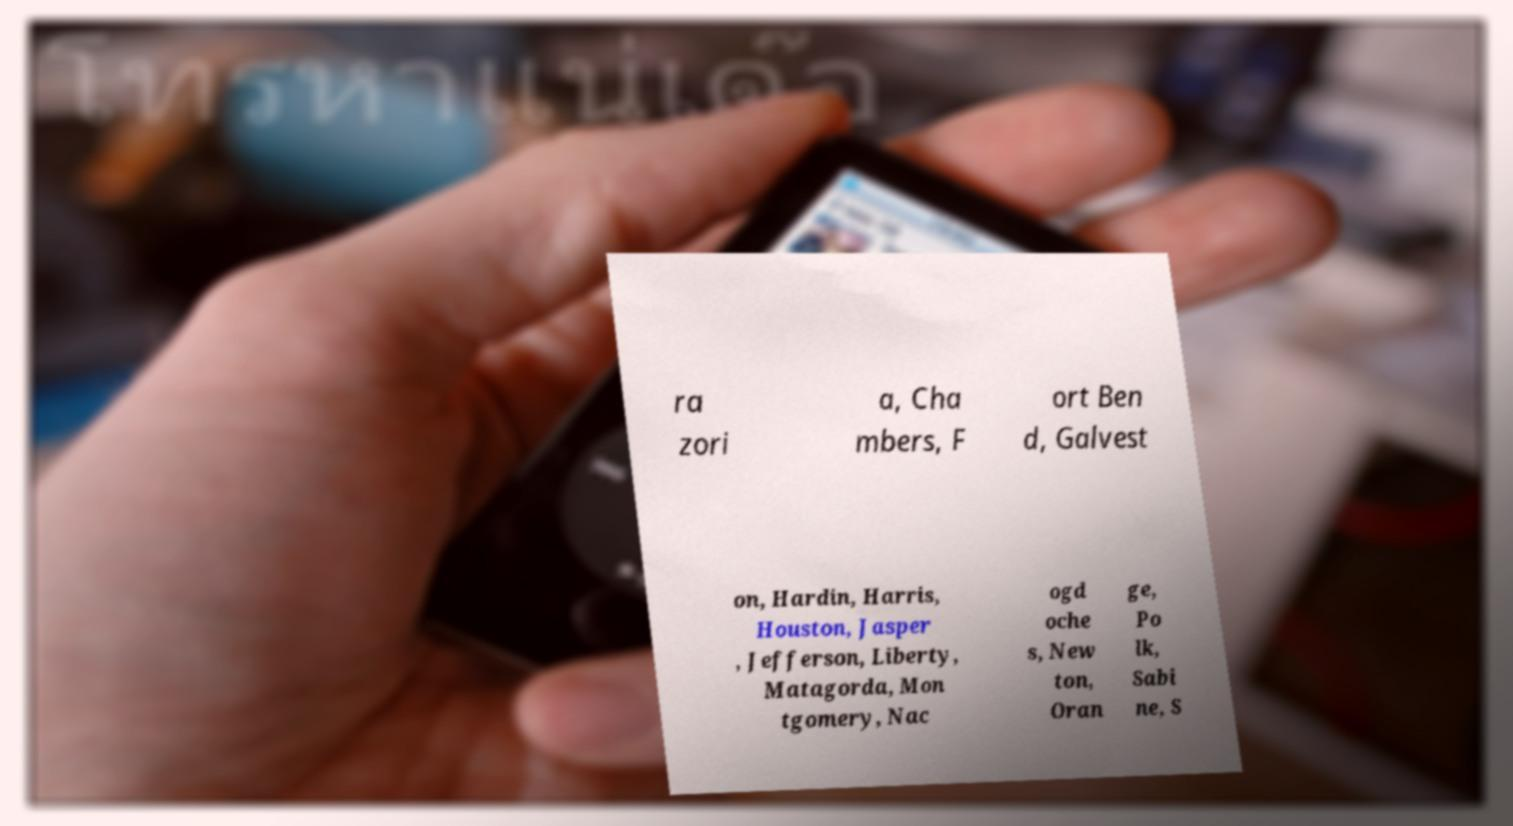Please identify and transcribe the text found in this image. ra zori a, Cha mbers, F ort Ben d, Galvest on, Hardin, Harris, Houston, Jasper , Jefferson, Liberty, Matagorda, Mon tgomery, Nac ogd oche s, New ton, Oran ge, Po lk, Sabi ne, S 